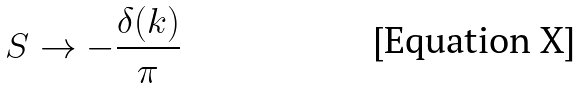Convert formula to latex. <formula><loc_0><loc_0><loc_500><loc_500>S \rightarrow - \frac { \delta ( k ) } { \pi }</formula> 